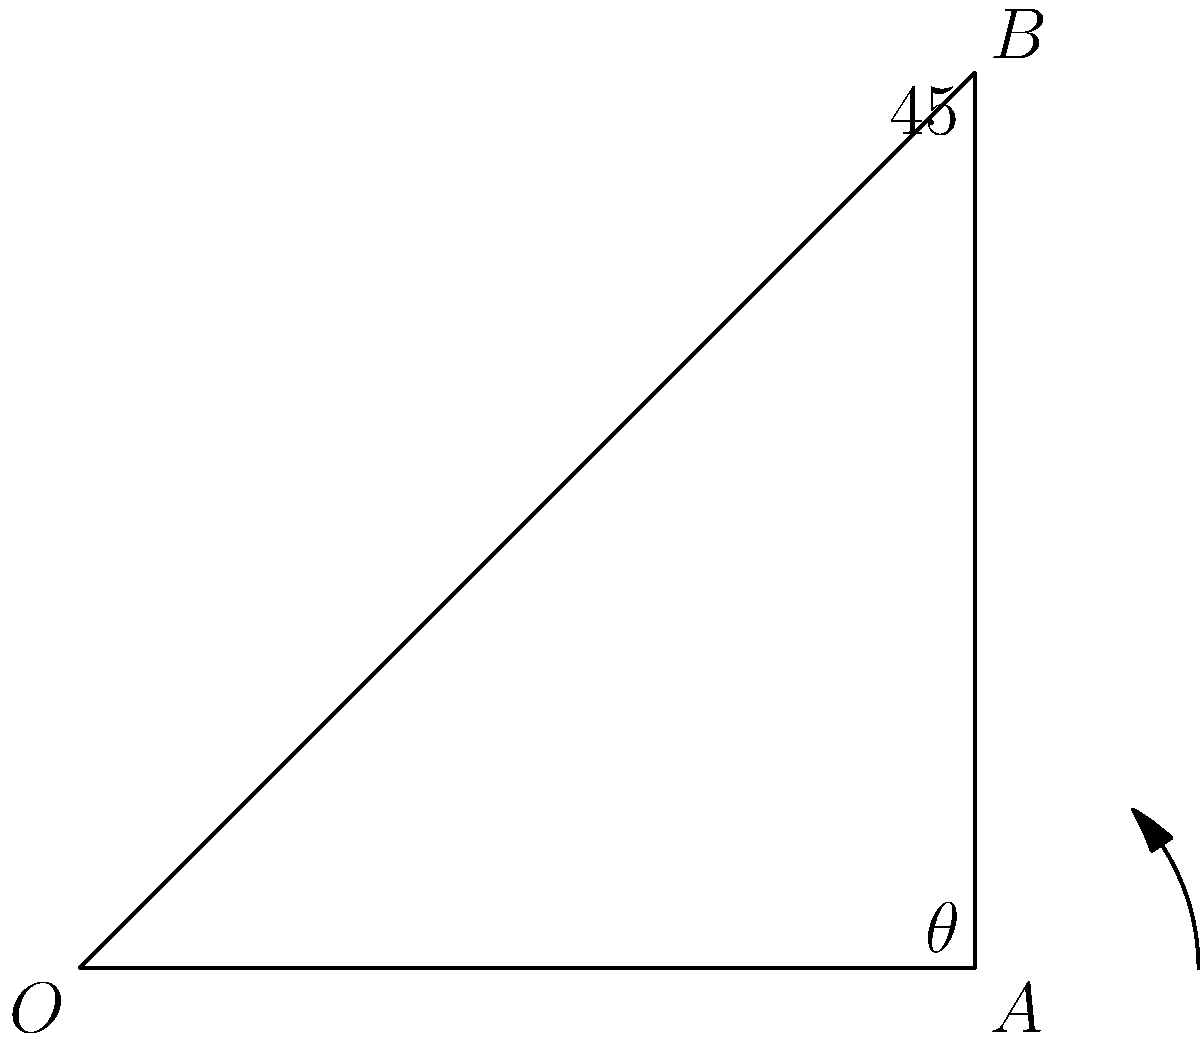In flower arranging, angled stem cuts can improve water absorption. If the optimal angle for water absorption is 45°, what should be the angle $\theta$ of the cut relative to the stem's length to achieve this optimal angle when placed in a vase? (Assume the vase bottom is horizontal) Let's approach this step-by-step:

1) In the diagram, OA represents the stem's length, and AB represents the cut surface.

2) The angle BOA is 45°, which is the optimal angle for water absorption when the stem is in the vase.

3) We need to find angle $\theta$, which is the angle between OA and AB.

4) In a right-angled triangle, the sum of all angles is 180°.

5) We know one angle is 90° (the right angle) and another is 45°.

6) Therefore, $\theta$ can be calculated as:

   $\theta = 180° - 90° - 45° = 45°$

7) This means the cut should be made at a 45° angle to the stem's length.

8) Interestingly, this results in a cut surface that will be parallel to the vase bottom when the stem is placed at the optimal 45° angle.
Answer: $45°$ 